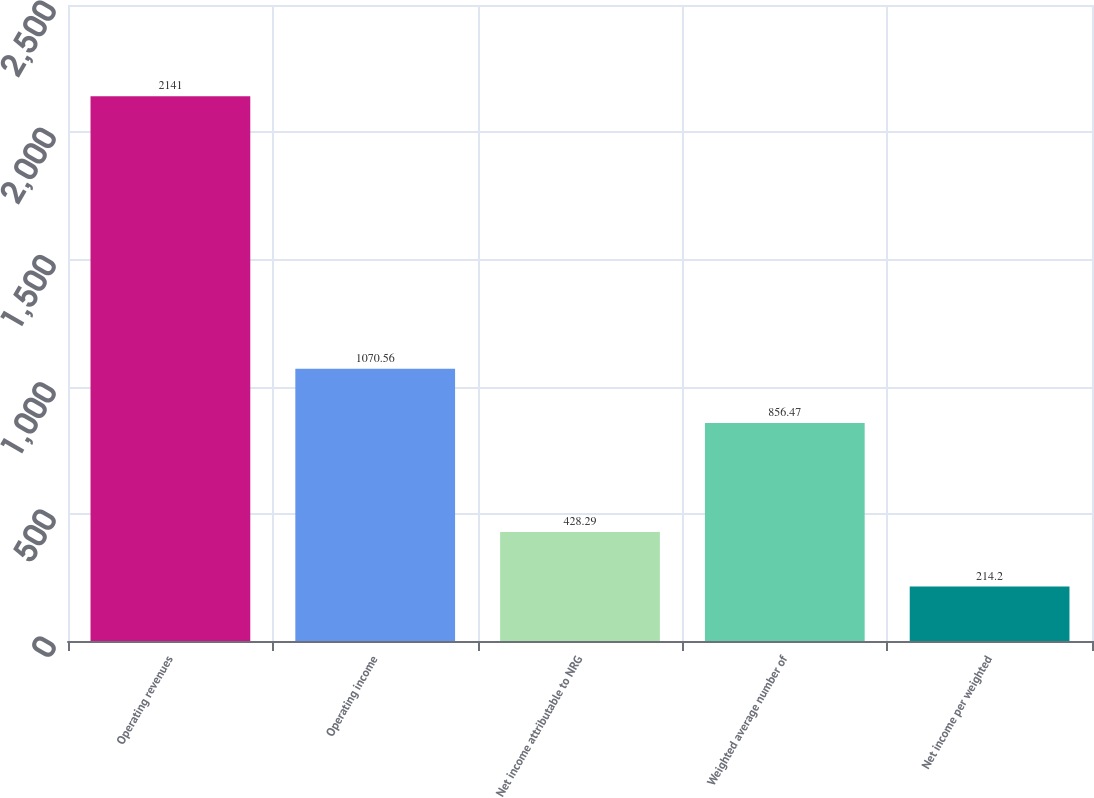Convert chart to OTSL. <chart><loc_0><loc_0><loc_500><loc_500><bar_chart><fcel>Operating revenues<fcel>Operating income<fcel>Net income attributable to NRG<fcel>Weighted average number of<fcel>Net income per weighted<nl><fcel>2141<fcel>1070.56<fcel>428.29<fcel>856.47<fcel>214.2<nl></chart> 